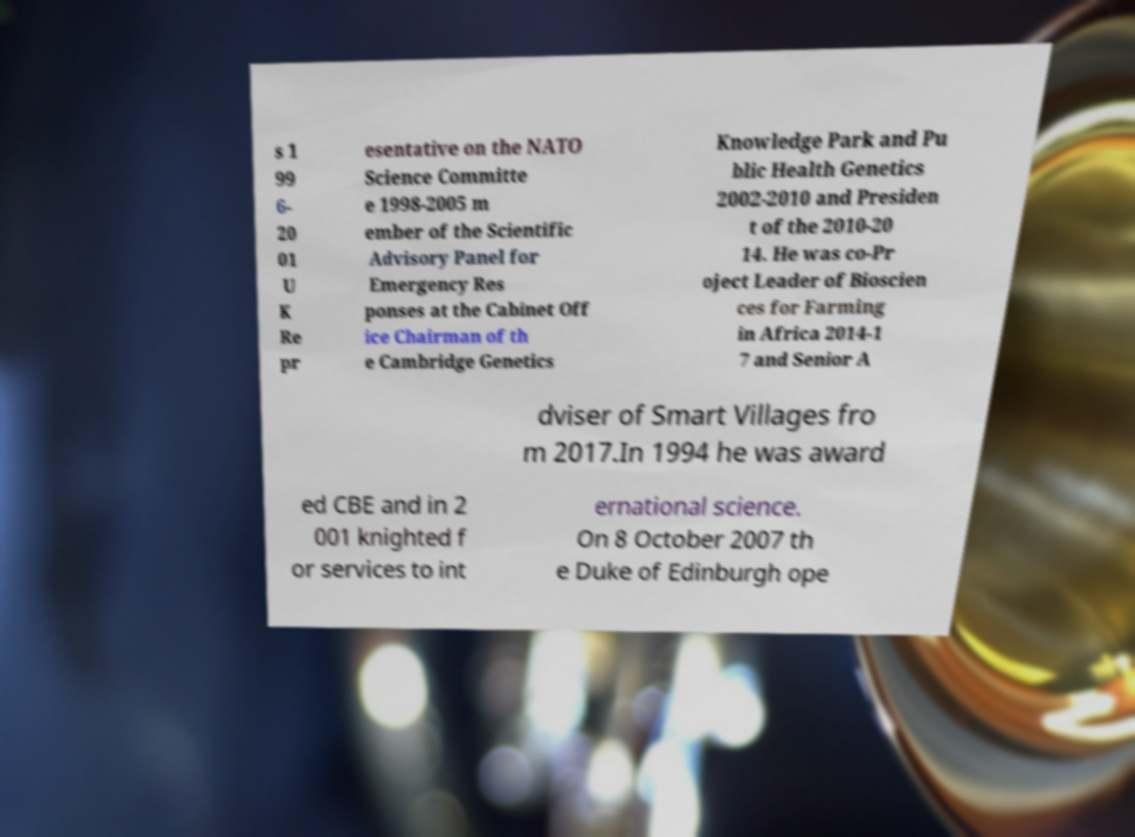Could you assist in decoding the text presented in this image and type it out clearly? s 1 99 6- 20 01 U K Re pr esentative on the NATO Science Committe e 1998-2005 m ember of the Scientific Advisory Panel for Emergency Res ponses at the Cabinet Off ice Chairman of th e Cambridge Genetics Knowledge Park and Pu blic Health Genetics 2002-2010 and Presiden t of the 2010-20 14. He was co-Pr oject Leader of Bioscien ces for Farming in Africa 2014-1 7 and Senior A dviser of Smart Villages fro m 2017.In 1994 he was award ed CBE and in 2 001 knighted f or services to int ernational science. On 8 October 2007 th e Duke of Edinburgh ope 